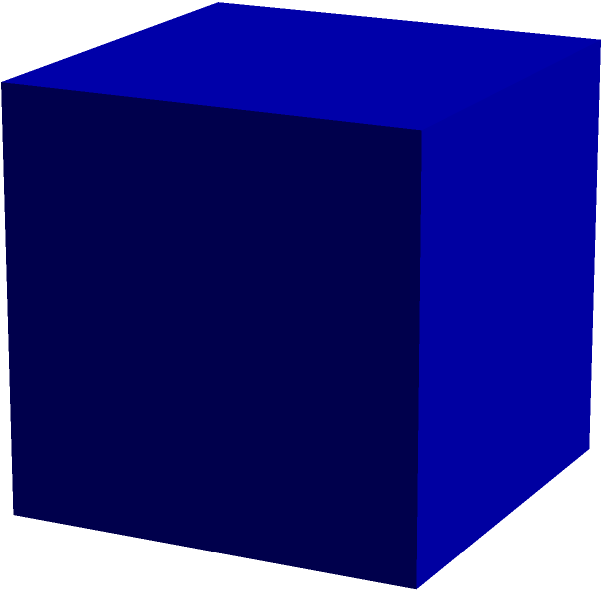A new public art installation in the town square of Mantua is a perfect cube with sides measuring 5 meters. The artist wants to cover all visible surfaces with a special reflective material. If the cube rests on the ground, how many square meters of the reflective material are needed to cover the visible surfaces? Let's approach this step-by-step:

1) First, we need to identify how many sides of the cube are visible. Since the cube rests on the ground, we can see:
   - The top face
   - Four side faces

2) The area of each face is a square. The formula for the area of a square is:
   $A = s^2$, where $s$ is the length of a side

3) Given that each side is 5 meters:
   Area of one face = $5^2 = 25$ square meters

4) We need to calculate the total area of 5 faces (4 sides + top):
   Total area = $5 * 25 = 125$ square meters

Therefore, the artist needs 125 square meters of reflective material to cover the visible surfaces of the cube.
Answer: 125 m² 